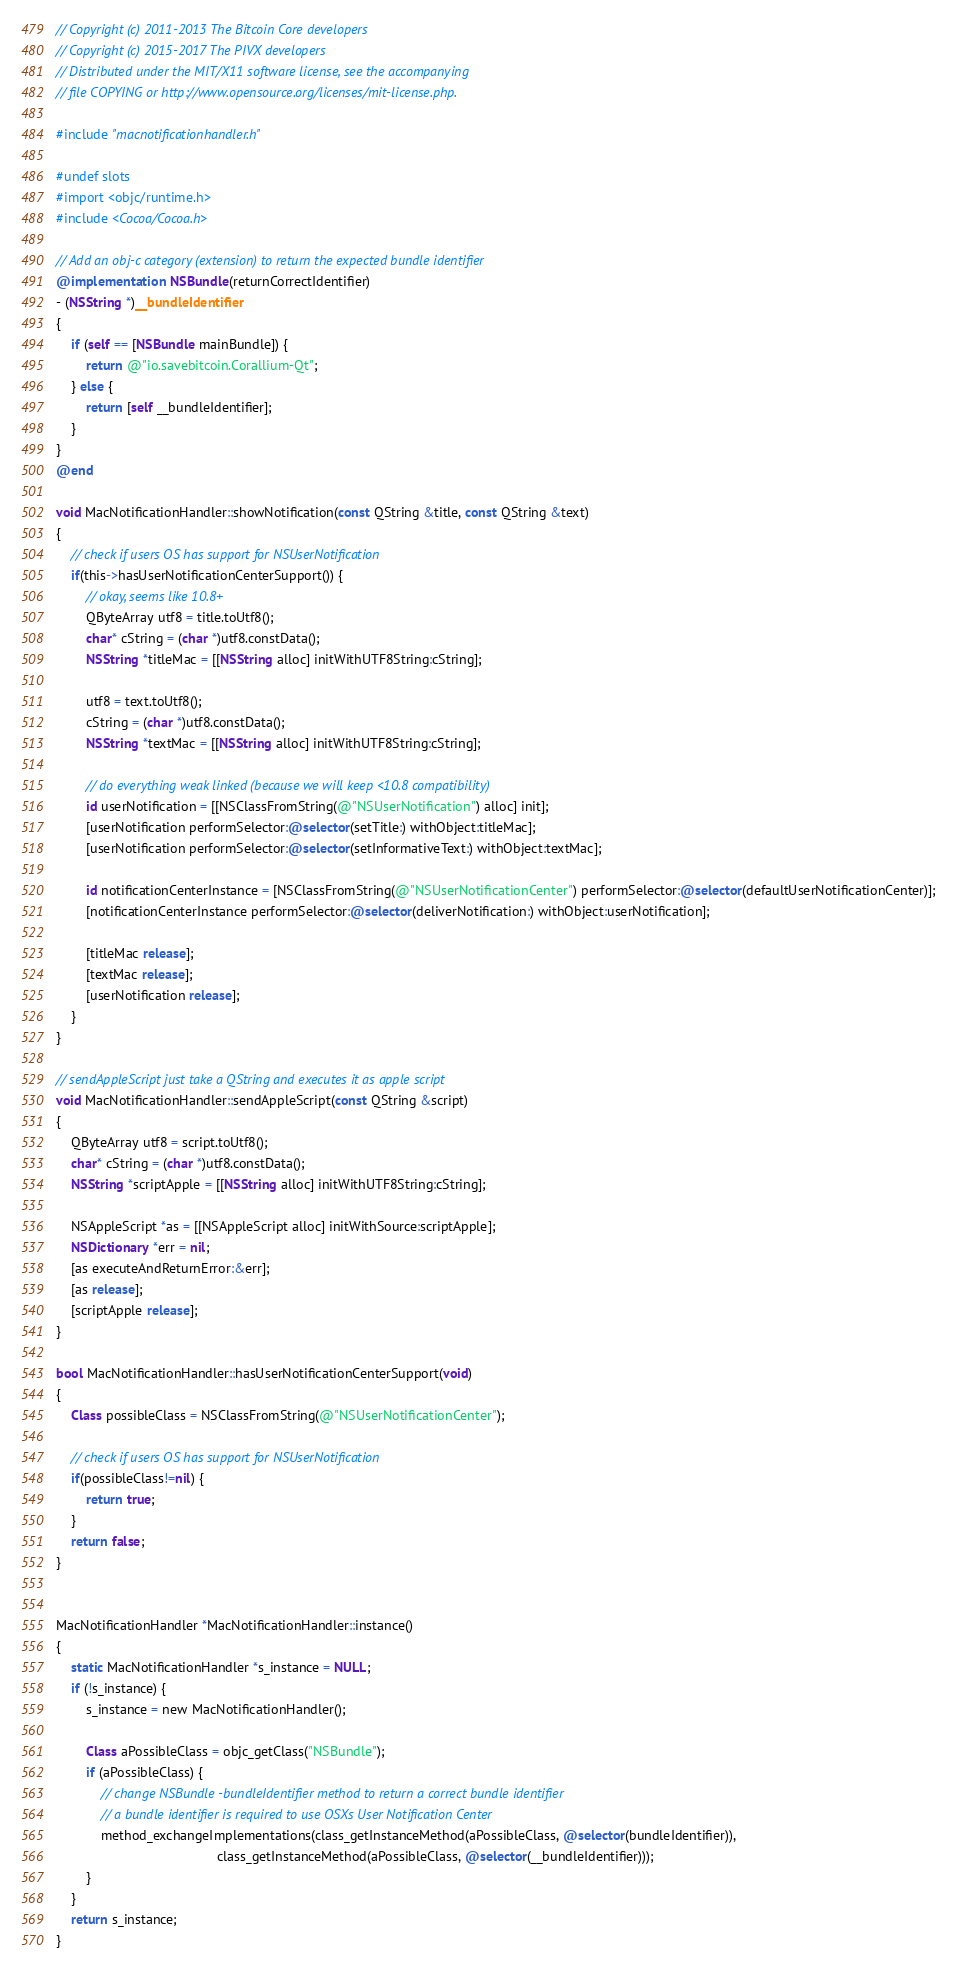<code> <loc_0><loc_0><loc_500><loc_500><_ObjectiveC_>// Copyright (c) 2011-2013 The Bitcoin Core developers
// Copyright (c) 2015-2017 The PIVX developers
// Distributed under the MIT/X11 software license, see the accompanying
// file COPYING or http://www.opensource.org/licenses/mit-license.php.

#include "macnotificationhandler.h"

#undef slots
#import <objc/runtime.h>
#include <Cocoa/Cocoa.h>

// Add an obj-c category (extension) to return the expected bundle identifier
@implementation NSBundle(returnCorrectIdentifier)
- (NSString *)__bundleIdentifier
{
    if (self == [NSBundle mainBundle]) {
        return @"io.savebitcoin.Corallium-Qt";
    } else {
        return [self __bundleIdentifier];
    }
}
@end

void MacNotificationHandler::showNotification(const QString &title, const QString &text)
{
    // check if users OS has support for NSUserNotification
    if(this->hasUserNotificationCenterSupport()) {
        // okay, seems like 10.8+
        QByteArray utf8 = title.toUtf8();
        char* cString = (char *)utf8.constData();
        NSString *titleMac = [[NSString alloc] initWithUTF8String:cString];

        utf8 = text.toUtf8();
        cString = (char *)utf8.constData();
        NSString *textMac = [[NSString alloc] initWithUTF8String:cString];

        // do everything weak linked (because we will keep <10.8 compatibility)
        id userNotification = [[NSClassFromString(@"NSUserNotification") alloc] init];
        [userNotification performSelector:@selector(setTitle:) withObject:titleMac];
        [userNotification performSelector:@selector(setInformativeText:) withObject:textMac];

        id notificationCenterInstance = [NSClassFromString(@"NSUserNotificationCenter") performSelector:@selector(defaultUserNotificationCenter)];
        [notificationCenterInstance performSelector:@selector(deliverNotification:) withObject:userNotification];

        [titleMac release];
        [textMac release];
        [userNotification release];
    }
}

// sendAppleScript just take a QString and executes it as apple script
void MacNotificationHandler::sendAppleScript(const QString &script)
{
    QByteArray utf8 = script.toUtf8();
    char* cString = (char *)utf8.constData();
    NSString *scriptApple = [[NSString alloc] initWithUTF8String:cString];

    NSAppleScript *as = [[NSAppleScript alloc] initWithSource:scriptApple];
    NSDictionary *err = nil;
    [as executeAndReturnError:&err];
    [as release];
    [scriptApple release];
}

bool MacNotificationHandler::hasUserNotificationCenterSupport(void)
{
    Class possibleClass = NSClassFromString(@"NSUserNotificationCenter");

    // check if users OS has support for NSUserNotification
    if(possibleClass!=nil) {
        return true;
    }
    return false;
}


MacNotificationHandler *MacNotificationHandler::instance()
{
    static MacNotificationHandler *s_instance = NULL;
    if (!s_instance) {
        s_instance = new MacNotificationHandler();
        
        Class aPossibleClass = objc_getClass("NSBundle");
        if (aPossibleClass) {
            // change NSBundle -bundleIdentifier method to return a correct bundle identifier
            // a bundle identifier is required to use OSXs User Notification Center
            method_exchangeImplementations(class_getInstanceMethod(aPossibleClass, @selector(bundleIdentifier)),
                                           class_getInstanceMethod(aPossibleClass, @selector(__bundleIdentifier)));
        }
    }
    return s_instance;
}
</code> 